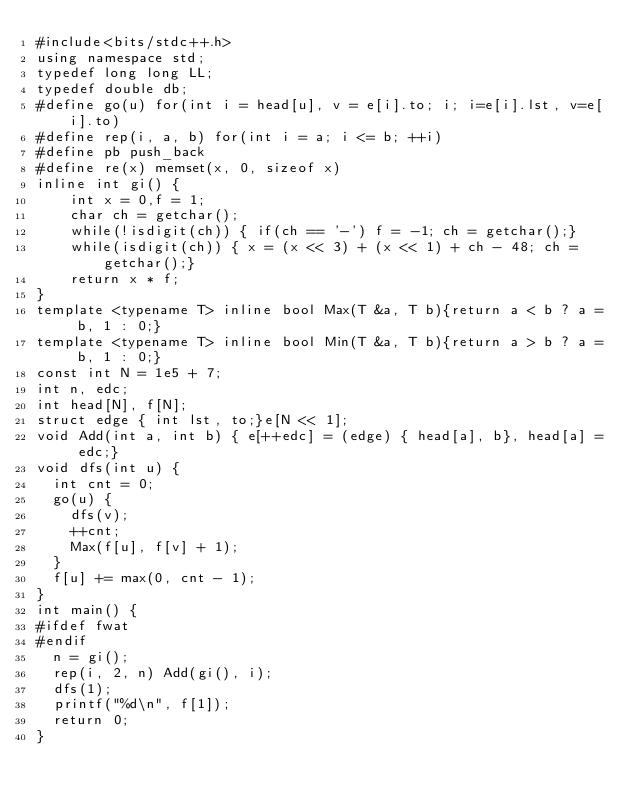Convert code to text. <code><loc_0><loc_0><loc_500><loc_500><_C++_>#include<bits/stdc++.h>
using namespace std;
typedef long long LL;
typedef double db;
#define go(u) for(int i = head[u], v = e[i].to; i; i=e[i].lst, v=e[i].to)
#define rep(i, a, b) for(int i = a; i <= b; ++i)
#define pb push_back
#define re(x) memset(x, 0, sizeof x)
inline int gi() {
    int x = 0,f = 1;
    char ch = getchar();
    while(!isdigit(ch)) { if(ch == '-') f = -1; ch = getchar();}
    while(isdigit(ch)) { x = (x << 3) + (x << 1) + ch - 48; ch = getchar();}
    return x * f;
}
template <typename T> inline bool Max(T &a, T b){return a < b ? a = b, 1 : 0;}
template <typename T> inline bool Min(T &a, T b){return a > b ? a = b, 1 : 0;}
const int N = 1e5 + 7;
int n, edc;
int head[N], f[N];
struct edge { int lst, to;}e[N << 1];
void Add(int a, int b) { e[++edc] = (edge) { head[a], b}, head[a] = edc;}
void dfs(int u) {
	int cnt = 0;
	go(u) {
		dfs(v);
		++cnt;
		Max(f[u], f[v] + 1);
	}
	f[u] += max(0, cnt - 1);
}
int main() {
#ifdef fwat
#endif
	n = gi();
	rep(i, 2, n) Add(gi(), i);
	dfs(1);
	printf("%d\n", f[1]);
	return 0;
}</code> 